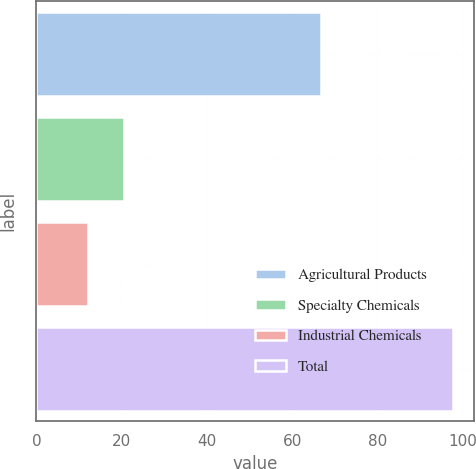Convert chart to OTSL. <chart><loc_0><loc_0><loc_500><loc_500><bar_chart><fcel>Agricultural Products<fcel>Specialty Chemicals<fcel>Industrial Chemicals<fcel>Total<nl><fcel>66.7<fcel>20.58<fcel>12<fcel>97.8<nl></chart> 